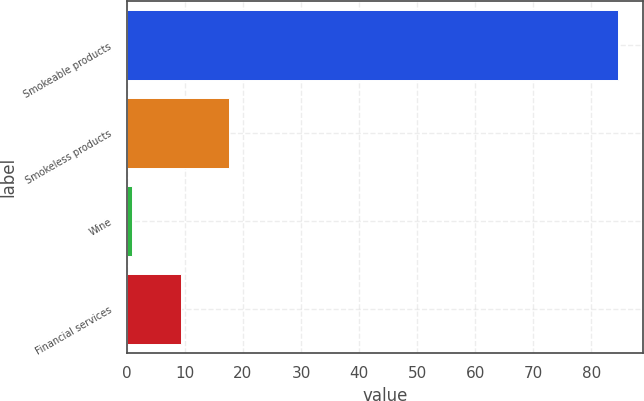<chart> <loc_0><loc_0><loc_500><loc_500><bar_chart><fcel>Smokeable products<fcel>Smokeless products<fcel>Wine<fcel>Financial services<nl><fcel>84.6<fcel>17.64<fcel>0.9<fcel>9.27<nl></chart> 